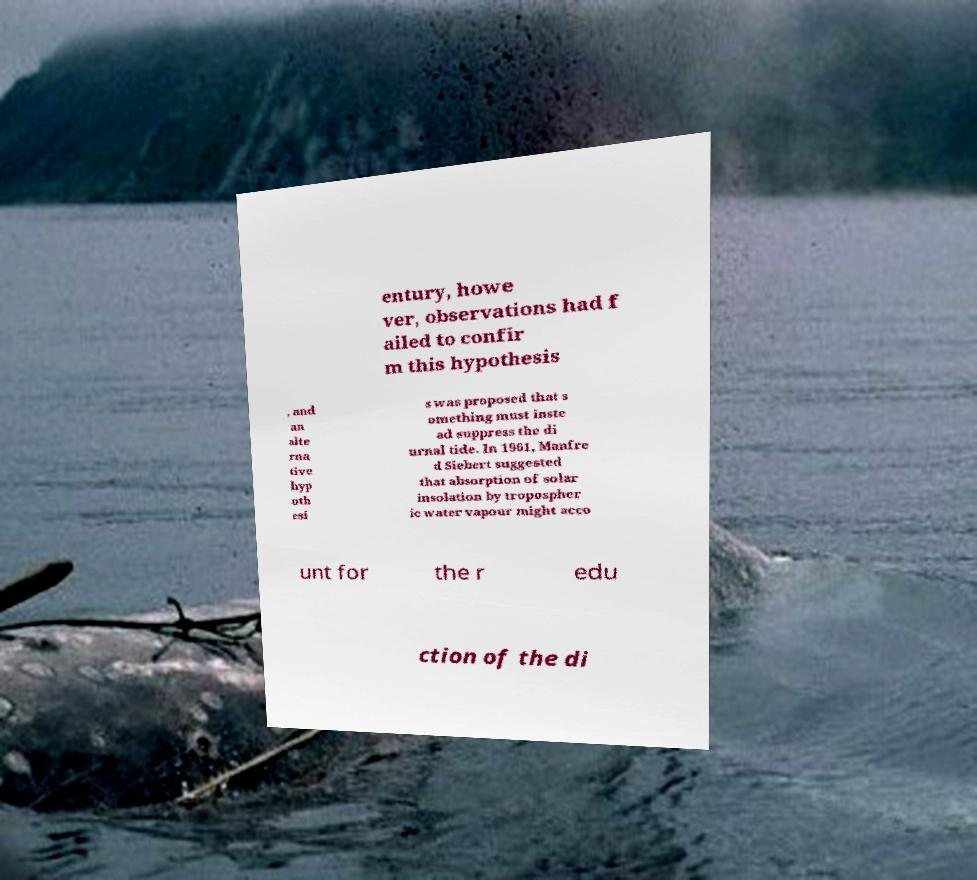There's text embedded in this image that I need extracted. Can you transcribe it verbatim? entury, howe ver, observations had f ailed to confir m this hypothesis , and an alte rna tive hyp oth esi s was proposed that s omething must inste ad suppress the di urnal tide. In 1961, Manfre d Siebert suggested that absorption of solar insolation by tropospher ic water vapour might acco unt for the r edu ction of the di 